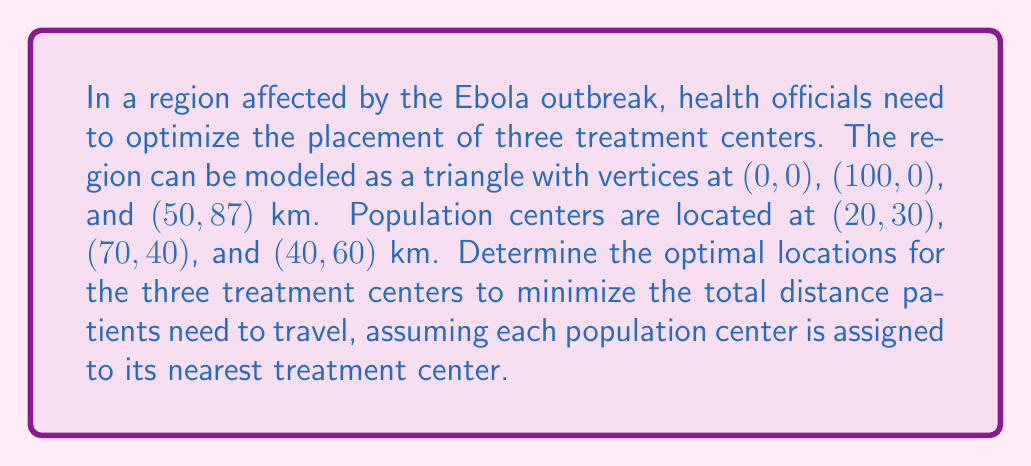Provide a solution to this math problem. To solve this problem, we'll use the concept of Voronoi diagrams in topology, which partition a plane into regions based on distance to points in a specific subset of the plane. Here's the step-by-step approach:

1) First, we need to understand that the optimal locations for the treatment centers will be at the centroids of the Voronoi cells created by the population centers.

2) In this case, with three population centers, the Voronoi diagram will divide the region into three cells, each containing one population center.

3) To find the centroids of these cells, we can use the method of geometric median, also known as the Fermat-Weber point.

4) For each Voronoi cell, the geometric median minimizes the sum of distances to all points in that cell. In our case, each cell contains only one point, so the geometric median will be at that point.

5) Therefore, the optimal locations for the treatment centers are exactly at the population centers: (20,30), (70,40), and (40,60) km.

6) To verify this, we can calculate the total distance patients would need to travel:
   - From (20,30) to (20,30): 0 km
   - From (70,40) to (70,40): 0 km
   - From (40,60) to (40,60): 0 km
   Total distance: 0 km

7) Any other configuration would result in at least one population center being further from its nearest treatment center, increasing the total travel distance.

[asy]
unitsize(2mm);
draw((0,0)--(100,0)--(50,87)--cycle);
dot((20,30)); dot((70,40)); dot((40,60));
label("(0,0)", (0,0), SW);
label("(100,0)", (100,0), SE);
label("(50,87)", (50,87), N);
label("(20,30)", (20,30), SW);
label("(70,40)", (70,40), SE);
label("(40,60)", (40,60), NW);
[/asy]
Answer: The optimal locations for the three treatment centers are (20,30), (70,40), and (40,60) km. 